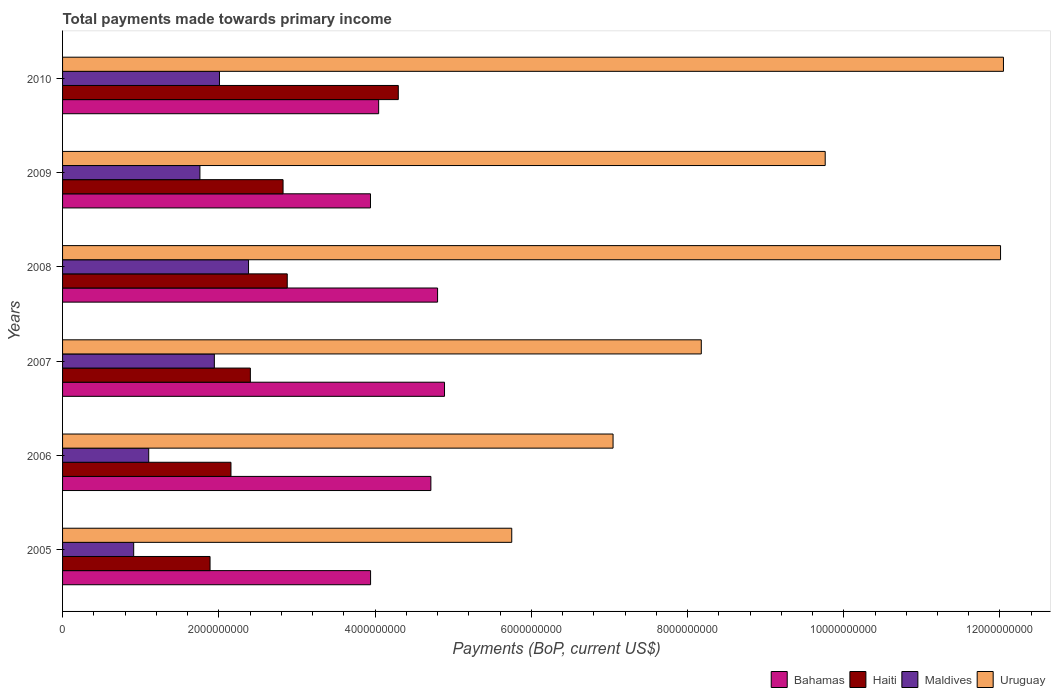Are the number of bars per tick equal to the number of legend labels?
Your answer should be compact. Yes. How many bars are there on the 3rd tick from the top?
Make the answer very short. 4. How many bars are there on the 5th tick from the bottom?
Your response must be concise. 4. What is the total payments made towards primary income in Haiti in 2006?
Offer a very short reply. 2.16e+09. Across all years, what is the maximum total payments made towards primary income in Haiti?
Make the answer very short. 4.30e+09. Across all years, what is the minimum total payments made towards primary income in Haiti?
Keep it short and to the point. 1.89e+09. In which year was the total payments made towards primary income in Bahamas maximum?
Offer a terse response. 2007. What is the total total payments made towards primary income in Bahamas in the graph?
Provide a succinct answer. 2.63e+1. What is the difference between the total payments made towards primary income in Maldives in 2005 and that in 2009?
Offer a very short reply. -8.48e+08. What is the difference between the total payments made towards primary income in Maldives in 2006 and the total payments made towards primary income in Bahamas in 2008?
Make the answer very short. -3.70e+09. What is the average total payments made towards primary income in Maldives per year?
Offer a terse response. 1.68e+09. In the year 2006, what is the difference between the total payments made towards primary income in Uruguay and total payments made towards primary income in Haiti?
Your answer should be very brief. 4.89e+09. In how many years, is the total payments made towards primary income in Bahamas greater than 10800000000 US$?
Provide a short and direct response. 0. What is the ratio of the total payments made towards primary income in Uruguay in 2006 to that in 2008?
Give a very brief answer. 0.59. What is the difference between the highest and the second highest total payments made towards primary income in Bahamas?
Ensure brevity in your answer.  8.88e+07. What is the difference between the highest and the lowest total payments made towards primary income in Haiti?
Give a very brief answer. 2.41e+09. In how many years, is the total payments made towards primary income in Bahamas greater than the average total payments made towards primary income in Bahamas taken over all years?
Provide a short and direct response. 3. What does the 1st bar from the top in 2010 represents?
Give a very brief answer. Uruguay. What does the 1st bar from the bottom in 2008 represents?
Offer a terse response. Bahamas. Is it the case that in every year, the sum of the total payments made towards primary income in Haiti and total payments made towards primary income in Bahamas is greater than the total payments made towards primary income in Maldives?
Offer a terse response. Yes. How many bars are there?
Provide a short and direct response. 24. How many years are there in the graph?
Make the answer very short. 6. What is the difference between two consecutive major ticks on the X-axis?
Offer a very short reply. 2.00e+09. Are the values on the major ticks of X-axis written in scientific E-notation?
Your answer should be compact. No. How are the legend labels stacked?
Your answer should be very brief. Horizontal. What is the title of the graph?
Your answer should be very brief. Total payments made towards primary income. What is the label or title of the X-axis?
Offer a terse response. Payments (BoP, current US$). What is the Payments (BoP, current US$) in Bahamas in 2005?
Offer a very short reply. 3.94e+09. What is the Payments (BoP, current US$) of Haiti in 2005?
Keep it short and to the point. 1.89e+09. What is the Payments (BoP, current US$) in Maldives in 2005?
Give a very brief answer. 9.10e+08. What is the Payments (BoP, current US$) of Uruguay in 2005?
Offer a very short reply. 5.75e+09. What is the Payments (BoP, current US$) in Bahamas in 2006?
Offer a terse response. 4.71e+09. What is the Payments (BoP, current US$) of Haiti in 2006?
Keep it short and to the point. 2.16e+09. What is the Payments (BoP, current US$) in Maldives in 2006?
Offer a very short reply. 1.10e+09. What is the Payments (BoP, current US$) in Uruguay in 2006?
Keep it short and to the point. 7.05e+09. What is the Payments (BoP, current US$) in Bahamas in 2007?
Provide a short and direct response. 4.89e+09. What is the Payments (BoP, current US$) of Haiti in 2007?
Ensure brevity in your answer.  2.40e+09. What is the Payments (BoP, current US$) of Maldives in 2007?
Give a very brief answer. 1.94e+09. What is the Payments (BoP, current US$) in Uruguay in 2007?
Offer a terse response. 8.18e+09. What is the Payments (BoP, current US$) of Bahamas in 2008?
Keep it short and to the point. 4.80e+09. What is the Payments (BoP, current US$) of Haiti in 2008?
Offer a very short reply. 2.88e+09. What is the Payments (BoP, current US$) in Maldives in 2008?
Your answer should be compact. 2.38e+09. What is the Payments (BoP, current US$) of Uruguay in 2008?
Provide a succinct answer. 1.20e+1. What is the Payments (BoP, current US$) of Bahamas in 2009?
Provide a short and direct response. 3.94e+09. What is the Payments (BoP, current US$) in Haiti in 2009?
Give a very brief answer. 2.82e+09. What is the Payments (BoP, current US$) of Maldives in 2009?
Offer a terse response. 1.76e+09. What is the Payments (BoP, current US$) in Uruguay in 2009?
Your answer should be very brief. 9.76e+09. What is the Payments (BoP, current US$) in Bahamas in 2010?
Give a very brief answer. 4.05e+09. What is the Payments (BoP, current US$) of Haiti in 2010?
Provide a succinct answer. 4.30e+09. What is the Payments (BoP, current US$) in Maldives in 2010?
Give a very brief answer. 2.01e+09. What is the Payments (BoP, current US$) in Uruguay in 2010?
Your response must be concise. 1.20e+1. Across all years, what is the maximum Payments (BoP, current US$) of Bahamas?
Provide a succinct answer. 4.89e+09. Across all years, what is the maximum Payments (BoP, current US$) of Haiti?
Your response must be concise. 4.30e+09. Across all years, what is the maximum Payments (BoP, current US$) in Maldives?
Offer a very short reply. 2.38e+09. Across all years, what is the maximum Payments (BoP, current US$) of Uruguay?
Your answer should be very brief. 1.20e+1. Across all years, what is the minimum Payments (BoP, current US$) in Bahamas?
Your answer should be compact. 3.94e+09. Across all years, what is the minimum Payments (BoP, current US$) of Haiti?
Your response must be concise. 1.89e+09. Across all years, what is the minimum Payments (BoP, current US$) in Maldives?
Your answer should be very brief. 9.10e+08. Across all years, what is the minimum Payments (BoP, current US$) in Uruguay?
Ensure brevity in your answer.  5.75e+09. What is the total Payments (BoP, current US$) in Bahamas in the graph?
Offer a very short reply. 2.63e+1. What is the total Payments (BoP, current US$) in Haiti in the graph?
Give a very brief answer. 1.64e+1. What is the total Payments (BoP, current US$) of Maldives in the graph?
Offer a very short reply. 1.01e+1. What is the total Payments (BoP, current US$) in Uruguay in the graph?
Your answer should be compact. 5.48e+1. What is the difference between the Payments (BoP, current US$) of Bahamas in 2005 and that in 2006?
Your answer should be very brief. -7.72e+08. What is the difference between the Payments (BoP, current US$) in Haiti in 2005 and that in 2006?
Ensure brevity in your answer.  -2.68e+08. What is the difference between the Payments (BoP, current US$) of Maldives in 2005 and that in 2006?
Your response must be concise. -1.92e+08. What is the difference between the Payments (BoP, current US$) in Uruguay in 2005 and that in 2006?
Your response must be concise. -1.30e+09. What is the difference between the Payments (BoP, current US$) in Bahamas in 2005 and that in 2007?
Give a very brief answer. -9.46e+08. What is the difference between the Payments (BoP, current US$) in Haiti in 2005 and that in 2007?
Provide a succinct answer. -5.16e+08. What is the difference between the Payments (BoP, current US$) of Maldives in 2005 and that in 2007?
Make the answer very short. -1.03e+09. What is the difference between the Payments (BoP, current US$) in Uruguay in 2005 and that in 2007?
Ensure brevity in your answer.  -2.43e+09. What is the difference between the Payments (BoP, current US$) in Bahamas in 2005 and that in 2008?
Your response must be concise. -8.58e+08. What is the difference between the Payments (BoP, current US$) in Haiti in 2005 and that in 2008?
Make the answer very short. -9.88e+08. What is the difference between the Payments (BoP, current US$) in Maldives in 2005 and that in 2008?
Make the answer very short. -1.47e+09. What is the difference between the Payments (BoP, current US$) of Uruguay in 2005 and that in 2008?
Your answer should be very brief. -6.26e+09. What is the difference between the Payments (BoP, current US$) in Bahamas in 2005 and that in 2009?
Give a very brief answer. 1.18e+06. What is the difference between the Payments (BoP, current US$) in Haiti in 2005 and that in 2009?
Give a very brief answer. -9.35e+08. What is the difference between the Payments (BoP, current US$) in Maldives in 2005 and that in 2009?
Offer a very short reply. -8.48e+08. What is the difference between the Payments (BoP, current US$) of Uruguay in 2005 and that in 2009?
Provide a succinct answer. -4.01e+09. What is the difference between the Payments (BoP, current US$) of Bahamas in 2005 and that in 2010?
Provide a short and direct response. -1.03e+08. What is the difference between the Payments (BoP, current US$) of Haiti in 2005 and that in 2010?
Provide a succinct answer. -2.41e+09. What is the difference between the Payments (BoP, current US$) of Maldives in 2005 and that in 2010?
Provide a short and direct response. -1.10e+09. What is the difference between the Payments (BoP, current US$) in Uruguay in 2005 and that in 2010?
Your answer should be compact. -6.29e+09. What is the difference between the Payments (BoP, current US$) of Bahamas in 2006 and that in 2007?
Your response must be concise. -1.75e+08. What is the difference between the Payments (BoP, current US$) of Haiti in 2006 and that in 2007?
Your answer should be compact. -2.48e+08. What is the difference between the Payments (BoP, current US$) of Maldives in 2006 and that in 2007?
Offer a terse response. -8.40e+08. What is the difference between the Payments (BoP, current US$) in Uruguay in 2006 and that in 2007?
Make the answer very short. -1.13e+09. What is the difference between the Payments (BoP, current US$) of Bahamas in 2006 and that in 2008?
Provide a short and direct response. -8.58e+07. What is the difference between the Payments (BoP, current US$) of Haiti in 2006 and that in 2008?
Provide a succinct answer. -7.20e+08. What is the difference between the Payments (BoP, current US$) in Maldives in 2006 and that in 2008?
Give a very brief answer. -1.28e+09. What is the difference between the Payments (BoP, current US$) in Uruguay in 2006 and that in 2008?
Give a very brief answer. -4.96e+09. What is the difference between the Payments (BoP, current US$) of Bahamas in 2006 and that in 2009?
Provide a succinct answer. 7.73e+08. What is the difference between the Payments (BoP, current US$) in Haiti in 2006 and that in 2009?
Give a very brief answer. -6.67e+08. What is the difference between the Payments (BoP, current US$) in Maldives in 2006 and that in 2009?
Ensure brevity in your answer.  -6.55e+08. What is the difference between the Payments (BoP, current US$) of Uruguay in 2006 and that in 2009?
Give a very brief answer. -2.72e+09. What is the difference between the Payments (BoP, current US$) of Bahamas in 2006 and that in 2010?
Your answer should be compact. 6.69e+08. What is the difference between the Payments (BoP, current US$) in Haiti in 2006 and that in 2010?
Your answer should be very brief. -2.14e+09. What is the difference between the Payments (BoP, current US$) in Maldives in 2006 and that in 2010?
Ensure brevity in your answer.  -9.06e+08. What is the difference between the Payments (BoP, current US$) in Uruguay in 2006 and that in 2010?
Your answer should be very brief. -5.00e+09. What is the difference between the Payments (BoP, current US$) of Bahamas in 2007 and that in 2008?
Give a very brief answer. 8.88e+07. What is the difference between the Payments (BoP, current US$) of Haiti in 2007 and that in 2008?
Your answer should be compact. -4.72e+08. What is the difference between the Payments (BoP, current US$) of Maldives in 2007 and that in 2008?
Make the answer very short. -4.38e+08. What is the difference between the Payments (BoP, current US$) of Uruguay in 2007 and that in 2008?
Provide a succinct answer. -3.83e+09. What is the difference between the Payments (BoP, current US$) of Bahamas in 2007 and that in 2009?
Your answer should be compact. 9.48e+08. What is the difference between the Payments (BoP, current US$) of Haiti in 2007 and that in 2009?
Keep it short and to the point. -4.19e+08. What is the difference between the Payments (BoP, current US$) in Maldives in 2007 and that in 2009?
Provide a short and direct response. 1.85e+08. What is the difference between the Payments (BoP, current US$) of Uruguay in 2007 and that in 2009?
Make the answer very short. -1.59e+09. What is the difference between the Payments (BoP, current US$) of Bahamas in 2007 and that in 2010?
Ensure brevity in your answer.  8.43e+08. What is the difference between the Payments (BoP, current US$) of Haiti in 2007 and that in 2010?
Your answer should be compact. -1.89e+09. What is the difference between the Payments (BoP, current US$) in Maldives in 2007 and that in 2010?
Provide a short and direct response. -6.55e+07. What is the difference between the Payments (BoP, current US$) of Uruguay in 2007 and that in 2010?
Give a very brief answer. -3.87e+09. What is the difference between the Payments (BoP, current US$) in Bahamas in 2008 and that in 2009?
Your answer should be very brief. 8.59e+08. What is the difference between the Payments (BoP, current US$) of Haiti in 2008 and that in 2009?
Keep it short and to the point. 5.37e+07. What is the difference between the Payments (BoP, current US$) of Maldives in 2008 and that in 2009?
Your answer should be compact. 6.23e+08. What is the difference between the Payments (BoP, current US$) of Uruguay in 2008 and that in 2009?
Make the answer very short. 2.24e+09. What is the difference between the Payments (BoP, current US$) in Bahamas in 2008 and that in 2010?
Keep it short and to the point. 7.54e+08. What is the difference between the Payments (BoP, current US$) of Haiti in 2008 and that in 2010?
Offer a very short reply. -1.42e+09. What is the difference between the Payments (BoP, current US$) of Maldives in 2008 and that in 2010?
Offer a terse response. 3.72e+08. What is the difference between the Payments (BoP, current US$) of Uruguay in 2008 and that in 2010?
Offer a terse response. -3.72e+07. What is the difference between the Payments (BoP, current US$) in Bahamas in 2009 and that in 2010?
Keep it short and to the point. -1.05e+08. What is the difference between the Payments (BoP, current US$) of Haiti in 2009 and that in 2010?
Give a very brief answer. -1.48e+09. What is the difference between the Payments (BoP, current US$) in Maldives in 2009 and that in 2010?
Make the answer very short. -2.50e+08. What is the difference between the Payments (BoP, current US$) of Uruguay in 2009 and that in 2010?
Your answer should be very brief. -2.28e+09. What is the difference between the Payments (BoP, current US$) in Bahamas in 2005 and the Payments (BoP, current US$) in Haiti in 2006?
Offer a very short reply. 1.79e+09. What is the difference between the Payments (BoP, current US$) of Bahamas in 2005 and the Payments (BoP, current US$) of Maldives in 2006?
Provide a succinct answer. 2.84e+09. What is the difference between the Payments (BoP, current US$) in Bahamas in 2005 and the Payments (BoP, current US$) in Uruguay in 2006?
Offer a terse response. -3.10e+09. What is the difference between the Payments (BoP, current US$) of Haiti in 2005 and the Payments (BoP, current US$) of Maldives in 2006?
Your response must be concise. 7.85e+08. What is the difference between the Payments (BoP, current US$) in Haiti in 2005 and the Payments (BoP, current US$) in Uruguay in 2006?
Offer a terse response. -5.16e+09. What is the difference between the Payments (BoP, current US$) in Maldives in 2005 and the Payments (BoP, current US$) in Uruguay in 2006?
Make the answer very short. -6.14e+09. What is the difference between the Payments (BoP, current US$) in Bahamas in 2005 and the Payments (BoP, current US$) in Haiti in 2007?
Provide a short and direct response. 1.54e+09. What is the difference between the Payments (BoP, current US$) in Bahamas in 2005 and the Payments (BoP, current US$) in Maldives in 2007?
Ensure brevity in your answer.  2.00e+09. What is the difference between the Payments (BoP, current US$) in Bahamas in 2005 and the Payments (BoP, current US$) in Uruguay in 2007?
Your answer should be very brief. -4.23e+09. What is the difference between the Payments (BoP, current US$) in Haiti in 2005 and the Payments (BoP, current US$) in Maldives in 2007?
Give a very brief answer. -5.51e+07. What is the difference between the Payments (BoP, current US$) in Haiti in 2005 and the Payments (BoP, current US$) in Uruguay in 2007?
Provide a short and direct response. -6.29e+09. What is the difference between the Payments (BoP, current US$) in Maldives in 2005 and the Payments (BoP, current US$) in Uruguay in 2007?
Keep it short and to the point. -7.27e+09. What is the difference between the Payments (BoP, current US$) of Bahamas in 2005 and the Payments (BoP, current US$) of Haiti in 2008?
Offer a very short reply. 1.07e+09. What is the difference between the Payments (BoP, current US$) in Bahamas in 2005 and the Payments (BoP, current US$) in Maldives in 2008?
Keep it short and to the point. 1.56e+09. What is the difference between the Payments (BoP, current US$) in Bahamas in 2005 and the Payments (BoP, current US$) in Uruguay in 2008?
Ensure brevity in your answer.  -8.06e+09. What is the difference between the Payments (BoP, current US$) of Haiti in 2005 and the Payments (BoP, current US$) of Maldives in 2008?
Provide a succinct answer. -4.93e+08. What is the difference between the Payments (BoP, current US$) of Haiti in 2005 and the Payments (BoP, current US$) of Uruguay in 2008?
Provide a short and direct response. -1.01e+1. What is the difference between the Payments (BoP, current US$) in Maldives in 2005 and the Payments (BoP, current US$) in Uruguay in 2008?
Your answer should be compact. -1.11e+1. What is the difference between the Payments (BoP, current US$) in Bahamas in 2005 and the Payments (BoP, current US$) in Haiti in 2009?
Make the answer very short. 1.12e+09. What is the difference between the Payments (BoP, current US$) in Bahamas in 2005 and the Payments (BoP, current US$) in Maldives in 2009?
Your answer should be compact. 2.18e+09. What is the difference between the Payments (BoP, current US$) of Bahamas in 2005 and the Payments (BoP, current US$) of Uruguay in 2009?
Offer a terse response. -5.82e+09. What is the difference between the Payments (BoP, current US$) of Haiti in 2005 and the Payments (BoP, current US$) of Maldives in 2009?
Keep it short and to the point. 1.30e+08. What is the difference between the Payments (BoP, current US$) of Haiti in 2005 and the Payments (BoP, current US$) of Uruguay in 2009?
Offer a very short reply. -7.87e+09. What is the difference between the Payments (BoP, current US$) of Maldives in 2005 and the Payments (BoP, current US$) of Uruguay in 2009?
Offer a terse response. -8.85e+09. What is the difference between the Payments (BoP, current US$) of Bahamas in 2005 and the Payments (BoP, current US$) of Haiti in 2010?
Make the answer very short. -3.55e+08. What is the difference between the Payments (BoP, current US$) of Bahamas in 2005 and the Payments (BoP, current US$) of Maldives in 2010?
Your answer should be very brief. 1.93e+09. What is the difference between the Payments (BoP, current US$) in Bahamas in 2005 and the Payments (BoP, current US$) in Uruguay in 2010?
Provide a short and direct response. -8.10e+09. What is the difference between the Payments (BoP, current US$) in Haiti in 2005 and the Payments (BoP, current US$) in Maldives in 2010?
Ensure brevity in your answer.  -1.21e+08. What is the difference between the Payments (BoP, current US$) in Haiti in 2005 and the Payments (BoP, current US$) in Uruguay in 2010?
Keep it short and to the point. -1.02e+1. What is the difference between the Payments (BoP, current US$) of Maldives in 2005 and the Payments (BoP, current US$) of Uruguay in 2010?
Provide a succinct answer. -1.11e+1. What is the difference between the Payments (BoP, current US$) in Bahamas in 2006 and the Payments (BoP, current US$) in Haiti in 2007?
Give a very brief answer. 2.31e+09. What is the difference between the Payments (BoP, current US$) in Bahamas in 2006 and the Payments (BoP, current US$) in Maldives in 2007?
Give a very brief answer. 2.77e+09. What is the difference between the Payments (BoP, current US$) in Bahamas in 2006 and the Payments (BoP, current US$) in Uruguay in 2007?
Provide a succinct answer. -3.46e+09. What is the difference between the Payments (BoP, current US$) of Haiti in 2006 and the Payments (BoP, current US$) of Maldives in 2007?
Offer a terse response. 2.13e+08. What is the difference between the Payments (BoP, current US$) of Haiti in 2006 and the Payments (BoP, current US$) of Uruguay in 2007?
Keep it short and to the point. -6.02e+09. What is the difference between the Payments (BoP, current US$) in Maldives in 2006 and the Payments (BoP, current US$) in Uruguay in 2007?
Offer a very short reply. -7.07e+09. What is the difference between the Payments (BoP, current US$) of Bahamas in 2006 and the Payments (BoP, current US$) of Haiti in 2008?
Your answer should be compact. 1.84e+09. What is the difference between the Payments (BoP, current US$) in Bahamas in 2006 and the Payments (BoP, current US$) in Maldives in 2008?
Keep it short and to the point. 2.33e+09. What is the difference between the Payments (BoP, current US$) in Bahamas in 2006 and the Payments (BoP, current US$) in Uruguay in 2008?
Give a very brief answer. -7.29e+09. What is the difference between the Payments (BoP, current US$) of Haiti in 2006 and the Payments (BoP, current US$) of Maldives in 2008?
Keep it short and to the point. -2.25e+08. What is the difference between the Payments (BoP, current US$) of Haiti in 2006 and the Payments (BoP, current US$) of Uruguay in 2008?
Keep it short and to the point. -9.85e+09. What is the difference between the Payments (BoP, current US$) in Maldives in 2006 and the Payments (BoP, current US$) in Uruguay in 2008?
Keep it short and to the point. -1.09e+1. What is the difference between the Payments (BoP, current US$) in Bahamas in 2006 and the Payments (BoP, current US$) in Haiti in 2009?
Your answer should be compact. 1.89e+09. What is the difference between the Payments (BoP, current US$) of Bahamas in 2006 and the Payments (BoP, current US$) of Maldives in 2009?
Offer a very short reply. 2.96e+09. What is the difference between the Payments (BoP, current US$) of Bahamas in 2006 and the Payments (BoP, current US$) of Uruguay in 2009?
Your response must be concise. -5.05e+09. What is the difference between the Payments (BoP, current US$) of Haiti in 2006 and the Payments (BoP, current US$) of Maldives in 2009?
Provide a short and direct response. 3.98e+08. What is the difference between the Payments (BoP, current US$) in Haiti in 2006 and the Payments (BoP, current US$) in Uruguay in 2009?
Give a very brief answer. -7.61e+09. What is the difference between the Payments (BoP, current US$) of Maldives in 2006 and the Payments (BoP, current US$) of Uruguay in 2009?
Give a very brief answer. -8.66e+09. What is the difference between the Payments (BoP, current US$) in Bahamas in 2006 and the Payments (BoP, current US$) in Haiti in 2010?
Make the answer very short. 4.17e+08. What is the difference between the Payments (BoP, current US$) in Bahamas in 2006 and the Payments (BoP, current US$) in Maldives in 2010?
Ensure brevity in your answer.  2.71e+09. What is the difference between the Payments (BoP, current US$) in Bahamas in 2006 and the Payments (BoP, current US$) in Uruguay in 2010?
Offer a very short reply. -7.33e+09. What is the difference between the Payments (BoP, current US$) of Haiti in 2006 and the Payments (BoP, current US$) of Maldives in 2010?
Provide a succinct answer. 1.47e+08. What is the difference between the Payments (BoP, current US$) in Haiti in 2006 and the Payments (BoP, current US$) in Uruguay in 2010?
Make the answer very short. -9.89e+09. What is the difference between the Payments (BoP, current US$) in Maldives in 2006 and the Payments (BoP, current US$) in Uruguay in 2010?
Provide a succinct answer. -1.09e+1. What is the difference between the Payments (BoP, current US$) in Bahamas in 2007 and the Payments (BoP, current US$) in Haiti in 2008?
Your response must be concise. 2.01e+09. What is the difference between the Payments (BoP, current US$) of Bahamas in 2007 and the Payments (BoP, current US$) of Maldives in 2008?
Your answer should be very brief. 2.51e+09. What is the difference between the Payments (BoP, current US$) of Bahamas in 2007 and the Payments (BoP, current US$) of Uruguay in 2008?
Provide a short and direct response. -7.12e+09. What is the difference between the Payments (BoP, current US$) of Haiti in 2007 and the Payments (BoP, current US$) of Maldives in 2008?
Your answer should be very brief. 2.33e+07. What is the difference between the Payments (BoP, current US$) of Haiti in 2007 and the Payments (BoP, current US$) of Uruguay in 2008?
Your response must be concise. -9.60e+09. What is the difference between the Payments (BoP, current US$) in Maldives in 2007 and the Payments (BoP, current US$) in Uruguay in 2008?
Make the answer very short. -1.01e+1. What is the difference between the Payments (BoP, current US$) of Bahamas in 2007 and the Payments (BoP, current US$) of Haiti in 2009?
Make the answer very short. 2.07e+09. What is the difference between the Payments (BoP, current US$) in Bahamas in 2007 and the Payments (BoP, current US$) in Maldives in 2009?
Make the answer very short. 3.13e+09. What is the difference between the Payments (BoP, current US$) in Bahamas in 2007 and the Payments (BoP, current US$) in Uruguay in 2009?
Your answer should be compact. -4.87e+09. What is the difference between the Payments (BoP, current US$) of Haiti in 2007 and the Payments (BoP, current US$) of Maldives in 2009?
Keep it short and to the point. 6.46e+08. What is the difference between the Payments (BoP, current US$) in Haiti in 2007 and the Payments (BoP, current US$) in Uruguay in 2009?
Keep it short and to the point. -7.36e+09. What is the difference between the Payments (BoP, current US$) in Maldives in 2007 and the Payments (BoP, current US$) in Uruguay in 2009?
Your answer should be very brief. -7.82e+09. What is the difference between the Payments (BoP, current US$) in Bahamas in 2007 and the Payments (BoP, current US$) in Haiti in 2010?
Give a very brief answer. 5.92e+08. What is the difference between the Payments (BoP, current US$) in Bahamas in 2007 and the Payments (BoP, current US$) in Maldives in 2010?
Provide a short and direct response. 2.88e+09. What is the difference between the Payments (BoP, current US$) in Bahamas in 2007 and the Payments (BoP, current US$) in Uruguay in 2010?
Your response must be concise. -7.15e+09. What is the difference between the Payments (BoP, current US$) in Haiti in 2007 and the Payments (BoP, current US$) in Maldives in 2010?
Provide a short and direct response. 3.96e+08. What is the difference between the Payments (BoP, current US$) of Haiti in 2007 and the Payments (BoP, current US$) of Uruguay in 2010?
Give a very brief answer. -9.64e+09. What is the difference between the Payments (BoP, current US$) of Maldives in 2007 and the Payments (BoP, current US$) of Uruguay in 2010?
Provide a succinct answer. -1.01e+1. What is the difference between the Payments (BoP, current US$) in Bahamas in 2008 and the Payments (BoP, current US$) in Haiti in 2009?
Make the answer very short. 1.98e+09. What is the difference between the Payments (BoP, current US$) in Bahamas in 2008 and the Payments (BoP, current US$) in Maldives in 2009?
Provide a short and direct response. 3.04e+09. What is the difference between the Payments (BoP, current US$) in Bahamas in 2008 and the Payments (BoP, current US$) in Uruguay in 2009?
Offer a very short reply. -4.96e+09. What is the difference between the Payments (BoP, current US$) of Haiti in 2008 and the Payments (BoP, current US$) of Maldives in 2009?
Keep it short and to the point. 1.12e+09. What is the difference between the Payments (BoP, current US$) of Haiti in 2008 and the Payments (BoP, current US$) of Uruguay in 2009?
Offer a terse response. -6.89e+09. What is the difference between the Payments (BoP, current US$) in Maldives in 2008 and the Payments (BoP, current US$) in Uruguay in 2009?
Offer a very short reply. -7.38e+09. What is the difference between the Payments (BoP, current US$) of Bahamas in 2008 and the Payments (BoP, current US$) of Haiti in 2010?
Provide a succinct answer. 5.03e+08. What is the difference between the Payments (BoP, current US$) of Bahamas in 2008 and the Payments (BoP, current US$) of Maldives in 2010?
Give a very brief answer. 2.79e+09. What is the difference between the Payments (BoP, current US$) in Bahamas in 2008 and the Payments (BoP, current US$) in Uruguay in 2010?
Give a very brief answer. -7.24e+09. What is the difference between the Payments (BoP, current US$) in Haiti in 2008 and the Payments (BoP, current US$) in Maldives in 2010?
Your answer should be very brief. 8.68e+08. What is the difference between the Payments (BoP, current US$) in Haiti in 2008 and the Payments (BoP, current US$) in Uruguay in 2010?
Your answer should be compact. -9.17e+09. What is the difference between the Payments (BoP, current US$) of Maldives in 2008 and the Payments (BoP, current US$) of Uruguay in 2010?
Ensure brevity in your answer.  -9.66e+09. What is the difference between the Payments (BoP, current US$) in Bahamas in 2009 and the Payments (BoP, current US$) in Haiti in 2010?
Provide a short and direct response. -3.56e+08. What is the difference between the Payments (BoP, current US$) in Bahamas in 2009 and the Payments (BoP, current US$) in Maldives in 2010?
Your response must be concise. 1.93e+09. What is the difference between the Payments (BoP, current US$) in Bahamas in 2009 and the Payments (BoP, current US$) in Uruguay in 2010?
Offer a terse response. -8.10e+09. What is the difference between the Payments (BoP, current US$) in Haiti in 2009 and the Payments (BoP, current US$) in Maldives in 2010?
Ensure brevity in your answer.  8.14e+08. What is the difference between the Payments (BoP, current US$) of Haiti in 2009 and the Payments (BoP, current US$) of Uruguay in 2010?
Keep it short and to the point. -9.22e+09. What is the difference between the Payments (BoP, current US$) in Maldives in 2009 and the Payments (BoP, current US$) in Uruguay in 2010?
Make the answer very short. -1.03e+1. What is the average Payments (BoP, current US$) in Bahamas per year?
Your answer should be compact. 4.39e+09. What is the average Payments (BoP, current US$) of Haiti per year?
Offer a terse response. 2.74e+09. What is the average Payments (BoP, current US$) of Maldives per year?
Ensure brevity in your answer.  1.68e+09. What is the average Payments (BoP, current US$) of Uruguay per year?
Make the answer very short. 9.13e+09. In the year 2005, what is the difference between the Payments (BoP, current US$) of Bahamas and Payments (BoP, current US$) of Haiti?
Make the answer very short. 2.05e+09. In the year 2005, what is the difference between the Payments (BoP, current US$) in Bahamas and Payments (BoP, current US$) in Maldives?
Your answer should be compact. 3.03e+09. In the year 2005, what is the difference between the Payments (BoP, current US$) in Bahamas and Payments (BoP, current US$) in Uruguay?
Make the answer very short. -1.81e+09. In the year 2005, what is the difference between the Payments (BoP, current US$) in Haiti and Payments (BoP, current US$) in Maldives?
Provide a short and direct response. 9.78e+08. In the year 2005, what is the difference between the Payments (BoP, current US$) of Haiti and Payments (BoP, current US$) of Uruguay?
Provide a short and direct response. -3.86e+09. In the year 2005, what is the difference between the Payments (BoP, current US$) of Maldives and Payments (BoP, current US$) of Uruguay?
Offer a very short reply. -4.84e+09. In the year 2006, what is the difference between the Payments (BoP, current US$) in Bahamas and Payments (BoP, current US$) in Haiti?
Your answer should be very brief. 2.56e+09. In the year 2006, what is the difference between the Payments (BoP, current US$) of Bahamas and Payments (BoP, current US$) of Maldives?
Ensure brevity in your answer.  3.61e+09. In the year 2006, what is the difference between the Payments (BoP, current US$) in Bahamas and Payments (BoP, current US$) in Uruguay?
Your answer should be compact. -2.33e+09. In the year 2006, what is the difference between the Payments (BoP, current US$) of Haiti and Payments (BoP, current US$) of Maldives?
Your response must be concise. 1.05e+09. In the year 2006, what is the difference between the Payments (BoP, current US$) of Haiti and Payments (BoP, current US$) of Uruguay?
Keep it short and to the point. -4.89e+09. In the year 2006, what is the difference between the Payments (BoP, current US$) of Maldives and Payments (BoP, current US$) of Uruguay?
Make the answer very short. -5.94e+09. In the year 2007, what is the difference between the Payments (BoP, current US$) of Bahamas and Payments (BoP, current US$) of Haiti?
Your answer should be compact. 2.49e+09. In the year 2007, what is the difference between the Payments (BoP, current US$) of Bahamas and Payments (BoP, current US$) of Maldives?
Give a very brief answer. 2.95e+09. In the year 2007, what is the difference between the Payments (BoP, current US$) in Bahamas and Payments (BoP, current US$) in Uruguay?
Your answer should be compact. -3.29e+09. In the year 2007, what is the difference between the Payments (BoP, current US$) in Haiti and Payments (BoP, current US$) in Maldives?
Your answer should be compact. 4.61e+08. In the year 2007, what is the difference between the Payments (BoP, current US$) of Haiti and Payments (BoP, current US$) of Uruguay?
Ensure brevity in your answer.  -5.77e+09. In the year 2007, what is the difference between the Payments (BoP, current US$) in Maldives and Payments (BoP, current US$) in Uruguay?
Give a very brief answer. -6.23e+09. In the year 2008, what is the difference between the Payments (BoP, current US$) in Bahamas and Payments (BoP, current US$) in Haiti?
Make the answer very short. 1.92e+09. In the year 2008, what is the difference between the Payments (BoP, current US$) in Bahamas and Payments (BoP, current US$) in Maldives?
Make the answer very short. 2.42e+09. In the year 2008, what is the difference between the Payments (BoP, current US$) of Bahamas and Payments (BoP, current US$) of Uruguay?
Your answer should be very brief. -7.21e+09. In the year 2008, what is the difference between the Payments (BoP, current US$) in Haiti and Payments (BoP, current US$) in Maldives?
Make the answer very short. 4.95e+08. In the year 2008, what is the difference between the Payments (BoP, current US$) of Haiti and Payments (BoP, current US$) of Uruguay?
Your answer should be compact. -9.13e+09. In the year 2008, what is the difference between the Payments (BoP, current US$) of Maldives and Payments (BoP, current US$) of Uruguay?
Make the answer very short. -9.63e+09. In the year 2009, what is the difference between the Payments (BoP, current US$) in Bahamas and Payments (BoP, current US$) in Haiti?
Offer a terse response. 1.12e+09. In the year 2009, what is the difference between the Payments (BoP, current US$) in Bahamas and Payments (BoP, current US$) in Maldives?
Offer a terse response. 2.18e+09. In the year 2009, what is the difference between the Payments (BoP, current US$) in Bahamas and Payments (BoP, current US$) in Uruguay?
Make the answer very short. -5.82e+09. In the year 2009, what is the difference between the Payments (BoP, current US$) of Haiti and Payments (BoP, current US$) of Maldives?
Offer a very short reply. 1.06e+09. In the year 2009, what is the difference between the Payments (BoP, current US$) in Haiti and Payments (BoP, current US$) in Uruguay?
Your answer should be very brief. -6.94e+09. In the year 2009, what is the difference between the Payments (BoP, current US$) in Maldives and Payments (BoP, current US$) in Uruguay?
Offer a very short reply. -8.00e+09. In the year 2010, what is the difference between the Payments (BoP, current US$) in Bahamas and Payments (BoP, current US$) in Haiti?
Keep it short and to the point. -2.51e+08. In the year 2010, what is the difference between the Payments (BoP, current US$) in Bahamas and Payments (BoP, current US$) in Maldives?
Your answer should be compact. 2.04e+09. In the year 2010, what is the difference between the Payments (BoP, current US$) of Bahamas and Payments (BoP, current US$) of Uruguay?
Provide a short and direct response. -8.00e+09. In the year 2010, what is the difference between the Payments (BoP, current US$) of Haiti and Payments (BoP, current US$) of Maldives?
Give a very brief answer. 2.29e+09. In the year 2010, what is the difference between the Payments (BoP, current US$) in Haiti and Payments (BoP, current US$) in Uruguay?
Offer a very short reply. -7.75e+09. In the year 2010, what is the difference between the Payments (BoP, current US$) in Maldives and Payments (BoP, current US$) in Uruguay?
Your answer should be compact. -1.00e+1. What is the ratio of the Payments (BoP, current US$) of Bahamas in 2005 to that in 2006?
Make the answer very short. 0.84. What is the ratio of the Payments (BoP, current US$) of Haiti in 2005 to that in 2006?
Offer a terse response. 0.88. What is the ratio of the Payments (BoP, current US$) of Maldives in 2005 to that in 2006?
Your answer should be very brief. 0.83. What is the ratio of the Payments (BoP, current US$) of Uruguay in 2005 to that in 2006?
Provide a short and direct response. 0.82. What is the ratio of the Payments (BoP, current US$) in Bahamas in 2005 to that in 2007?
Your answer should be compact. 0.81. What is the ratio of the Payments (BoP, current US$) of Haiti in 2005 to that in 2007?
Keep it short and to the point. 0.79. What is the ratio of the Payments (BoP, current US$) of Maldives in 2005 to that in 2007?
Ensure brevity in your answer.  0.47. What is the ratio of the Payments (BoP, current US$) of Uruguay in 2005 to that in 2007?
Your answer should be compact. 0.7. What is the ratio of the Payments (BoP, current US$) in Bahamas in 2005 to that in 2008?
Ensure brevity in your answer.  0.82. What is the ratio of the Payments (BoP, current US$) of Haiti in 2005 to that in 2008?
Ensure brevity in your answer.  0.66. What is the ratio of the Payments (BoP, current US$) in Maldives in 2005 to that in 2008?
Give a very brief answer. 0.38. What is the ratio of the Payments (BoP, current US$) in Uruguay in 2005 to that in 2008?
Your answer should be compact. 0.48. What is the ratio of the Payments (BoP, current US$) in Bahamas in 2005 to that in 2009?
Ensure brevity in your answer.  1. What is the ratio of the Payments (BoP, current US$) in Haiti in 2005 to that in 2009?
Your response must be concise. 0.67. What is the ratio of the Payments (BoP, current US$) of Maldives in 2005 to that in 2009?
Offer a very short reply. 0.52. What is the ratio of the Payments (BoP, current US$) of Uruguay in 2005 to that in 2009?
Your answer should be compact. 0.59. What is the ratio of the Payments (BoP, current US$) of Bahamas in 2005 to that in 2010?
Your response must be concise. 0.97. What is the ratio of the Payments (BoP, current US$) of Haiti in 2005 to that in 2010?
Your answer should be compact. 0.44. What is the ratio of the Payments (BoP, current US$) in Maldives in 2005 to that in 2010?
Your answer should be very brief. 0.45. What is the ratio of the Payments (BoP, current US$) of Uruguay in 2005 to that in 2010?
Ensure brevity in your answer.  0.48. What is the ratio of the Payments (BoP, current US$) of Haiti in 2006 to that in 2007?
Offer a terse response. 0.9. What is the ratio of the Payments (BoP, current US$) of Maldives in 2006 to that in 2007?
Offer a terse response. 0.57. What is the ratio of the Payments (BoP, current US$) of Uruguay in 2006 to that in 2007?
Your answer should be very brief. 0.86. What is the ratio of the Payments (BoP, current US$) in Bahamas in 2006 to that in 2008?
Give a very brief answer. 0.98. What is the ratio of the Payments (BoP, current US$) in Haiti in 2006 to that in 2008?
Give a very brief answer. 0.75. What is the ratio of the Payments (BoP, current US$) in Maldives in 2006 to that in 2008?
Make the answer very short. 0.46. What is the ratio of the Payments (BoP, current US$) of Uruguay in 2006 to that in 2008?
Give a very brief answer. 0.59. What is the ratio of the Payments (BoP, current US$) of Bahamas in 2006 to that in 2009?
Ensure brevity in your answer.  1.2. What is the ratio of the Payments (BoP, current US$) of Haiti in 2006 to that in 2009?
Keep it short and to the point. 0.76. What is the ratio of the Payments (BoP, current US$) in Maldives in 2006 to that in 2009?
Ensure brevity in your answer.  0.63. What is the ratio of the Payments (BoP, current US$) of Uruguay in 2006 to that in 2009?
Offer a very short reply. 0.72. What is the ratio of the Payments (BoP, current US$) of Bahamas in 2006 to that in 2010?
Provide a short and direct response. 1.17. What is the ratio of the Payments (BoP, current US$) of Haiti in 2006 to that in 2010?
Provide a short and direct response. 0.5. What is the ratio of the Payments (BoP, current US$) in Maldives in 2006 to that in 2010?
Offer a terse response. 0.55. What is the ratio of the Payments (BoP, current US$) of Uruguay in 2006 to that in 2010?
Your response must be concise. 0.59. What is the ratio of the Payments (BoP, current US$) in Bahamas in 2007 to that in 2008?
Offer a very short reply. 1.02. What is the ratio of the Payments (BoP, current US$) of Haiti in 2007 to that in 2008?
Ensure brevity in your answer.  0.84. What is the ratio of the Payments (BoP, current US$) of Maldives in 2007 to that in 2008?
Offer a terse response. 0.82. What is the ratio of the Payments (BoP, current US$) in Uruguay in 2007 to that in 2008?
Ensure brevity in your answer.  0.68. What is the ratio of the Payments (BoP, current US$) of Bahamas in 2007 to that in 2009?
Offer a very short reply. 1.24. What is the ratio of the Payments (BoP, current US$) in Haiti in 2007 to that in 2009?
Your answer should be very brief. 0.85. What is the ratio of the Payments (BoP, current US$) in Maldives in 2007 to that in 2009?
Make the answer very short. 1.11. What is the ratio of the Payments (BoP, current US$) of Uruguay in 2007 to that in 2009?
Give a very brief answer. 0.84. What is the ratio of the Payments (BoP, current US$) in Bahamas in 2007 to that in 2010?
Provide a succinct answer. 1.21. What is the ratio of the Payments (BoP, current US$) in Haiti in 2007 to that in 2010?
Your answer should be compact. 0.56. What is the ratio of the Payments (BoP, current US$) of Maldives in 2007 to that in 2010?
Keep it short and to the point. 0.97. What is the ratio of the Payments (BoP, current US$) of Uruguay in 2007 to that in 2010?
Offer a terse response. 0.68. What is the ratio of the Payments (BoP, current US$) in Bahamas in 2008 to that in 2009?
Offer a terse response. 1.22. What is the ratio of the Payments (BoP, current US$) of Haiti in 2008 to that in 2009?
Your response must be concise. 1.02. What is the ratio of the Payments (BoP, current US$) of Maldives in 2008 to that in 2009?
Keep it short and to the point. 1.35. What is the ratio of the Payments (BoP, current US$) of Uruguay in 2008 to that in 2009?
Your response must be concise. 1.23. What is the ratio of the Payments (BoP, current US$) of Bahamas in 2008 to that in 2010?
Your answer should be very brief. 1.19. What is the ratio of the Payments (BoP, current US$) of Haiti in 2008 to that in 2010?
Offer a terse response. 0.67. What is the ratio of the Payments (BoP, current US$) of Maldives in 2008 to that in 2010?
Provide a short and direct response. 1.19. What is the ratio of the Payments (BoP, current US$) of Bahamas in 2009 to that in 2010?
Provide a short and direct response. 0.97. What is the ratio of the Payments (BoP, current US$) in Haiti in 2009 to that in 2010?
Your answer should be compact. 0.66. What is the ratio of the Payments (BoP, current US$) of Maldives in 2009 to that in 2010?
Keep it short and to the point. 0.88. What is the ratio of the Payments (BoP, current US$) in Uruguay in 2009 to that in 2010?
Your answer should be very brief. 0.81. What is the difference between the highest and the second highest Payments (BoP, current US$) in Bahamas?
Your answer should be compact. 8.88e+07. What is the difference between the highest and the second highest Payments (BoP, current US$) of Haiti?
Your answer should be compact. 1.42e+09. What is the difference between the highest and the second highest Payments (BoP, current US$) of Maldives?
Offer a very short reply. 3.72e+08. What is the difference between the highest and the second highest Payments (BoP, current US$) of Uruguay?
Provide a succinct answer. 3.72e+07. What is the difference between the highest and the lowest Payments (BoP, current US$) in Bahamas?
Keep it short and to the point. 9.48e+08. What is the difference between the highest and the lowest Payments (BoP, current US$) in Haiti?
Give a very brief answer. 2.41e+09. What is the difference between the highest and the lowest Payments (BoP, current US$) of Maldives?
Give a very brief answer. 1.47e+09. What is the difference between the highest and the lowest Payments (BoP, current US$) in Uruguay?
Provide a short and direct response. 6.29e+09. 